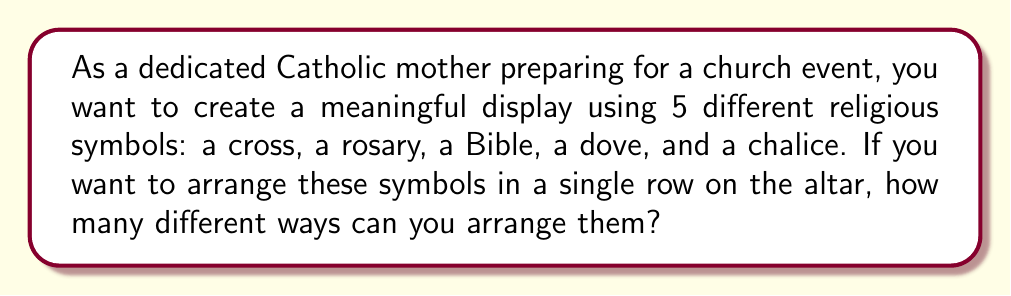Can you solve this math problem? Let's approach this step-by-step:

1) This is a permutation problem. We are arranging all 5 symbols, and the order matters.

2) The formula for permutations of n distinct objects is:

   $$P(n) = n!$$

   Where $n!$ (n factorial) is the product of all positive integers less than or equal to n.

3) In this case, we have 5 distinct symbols, so $n = 5$.

4) Let's calculate $5!$:

   $$5! = 5 \times 4 \times 3 \times 2 \times 1 = 120$$

5) Therefore, there are 120 different ways to arrange these 5 religious symbols.

To visualize this, we can think of it as:
- We have 5 choices for the first position
- Then 4 choices for the second position
- 3 for the third
- 2 for the fourth
- And only 1 choice left for the last position

This gives us: $5 \times 4 \times 3 \times 2 \times 1 = 120$
Answer: 120 different arrangements 